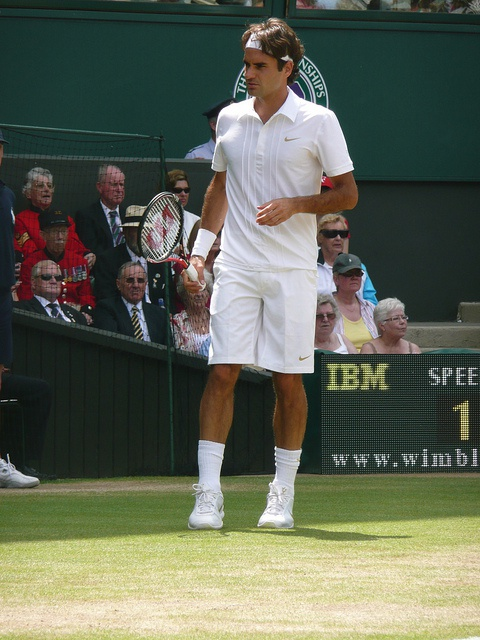Describe the objects in this image and their specific colors. I can see people in black, lightgray, darkgray, and maroon tones, people in black, darkgray, gray, and lightgray tones, people in black, maroon, and gray tones, people in black, gray, and maroon tones, and people in black, darkgray, and gray tones in this image. 